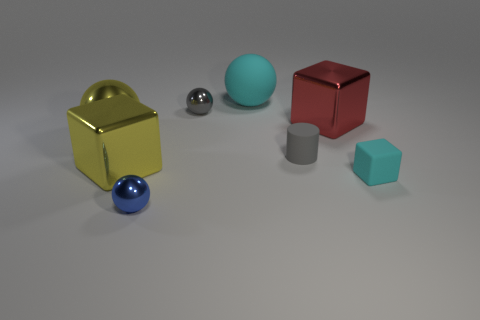Add 1 big cubes. How many objects exist? 9 Subtract all big yellow spheres. How many spheres are left? 3 Subtract all blocks. How many objects are left? 5 Subtract 2 spheres. How many spheres are left? 2 Subtract all yellow balls. How many balls are left? 3 Subtract all gray spheres. Subtract all yellow cylinders. How many spheres are left? 3 Subtract all green matte cylinders. Subtract all tiny blue metal objects. How many objects are left? 7 Add 6 gray matte things. How many gray matte things are left? 7 Add 3 tiny red metal things. How many tiny red metal things exist? 3 Subtract 0 red spheres. How many objects are left? 8 